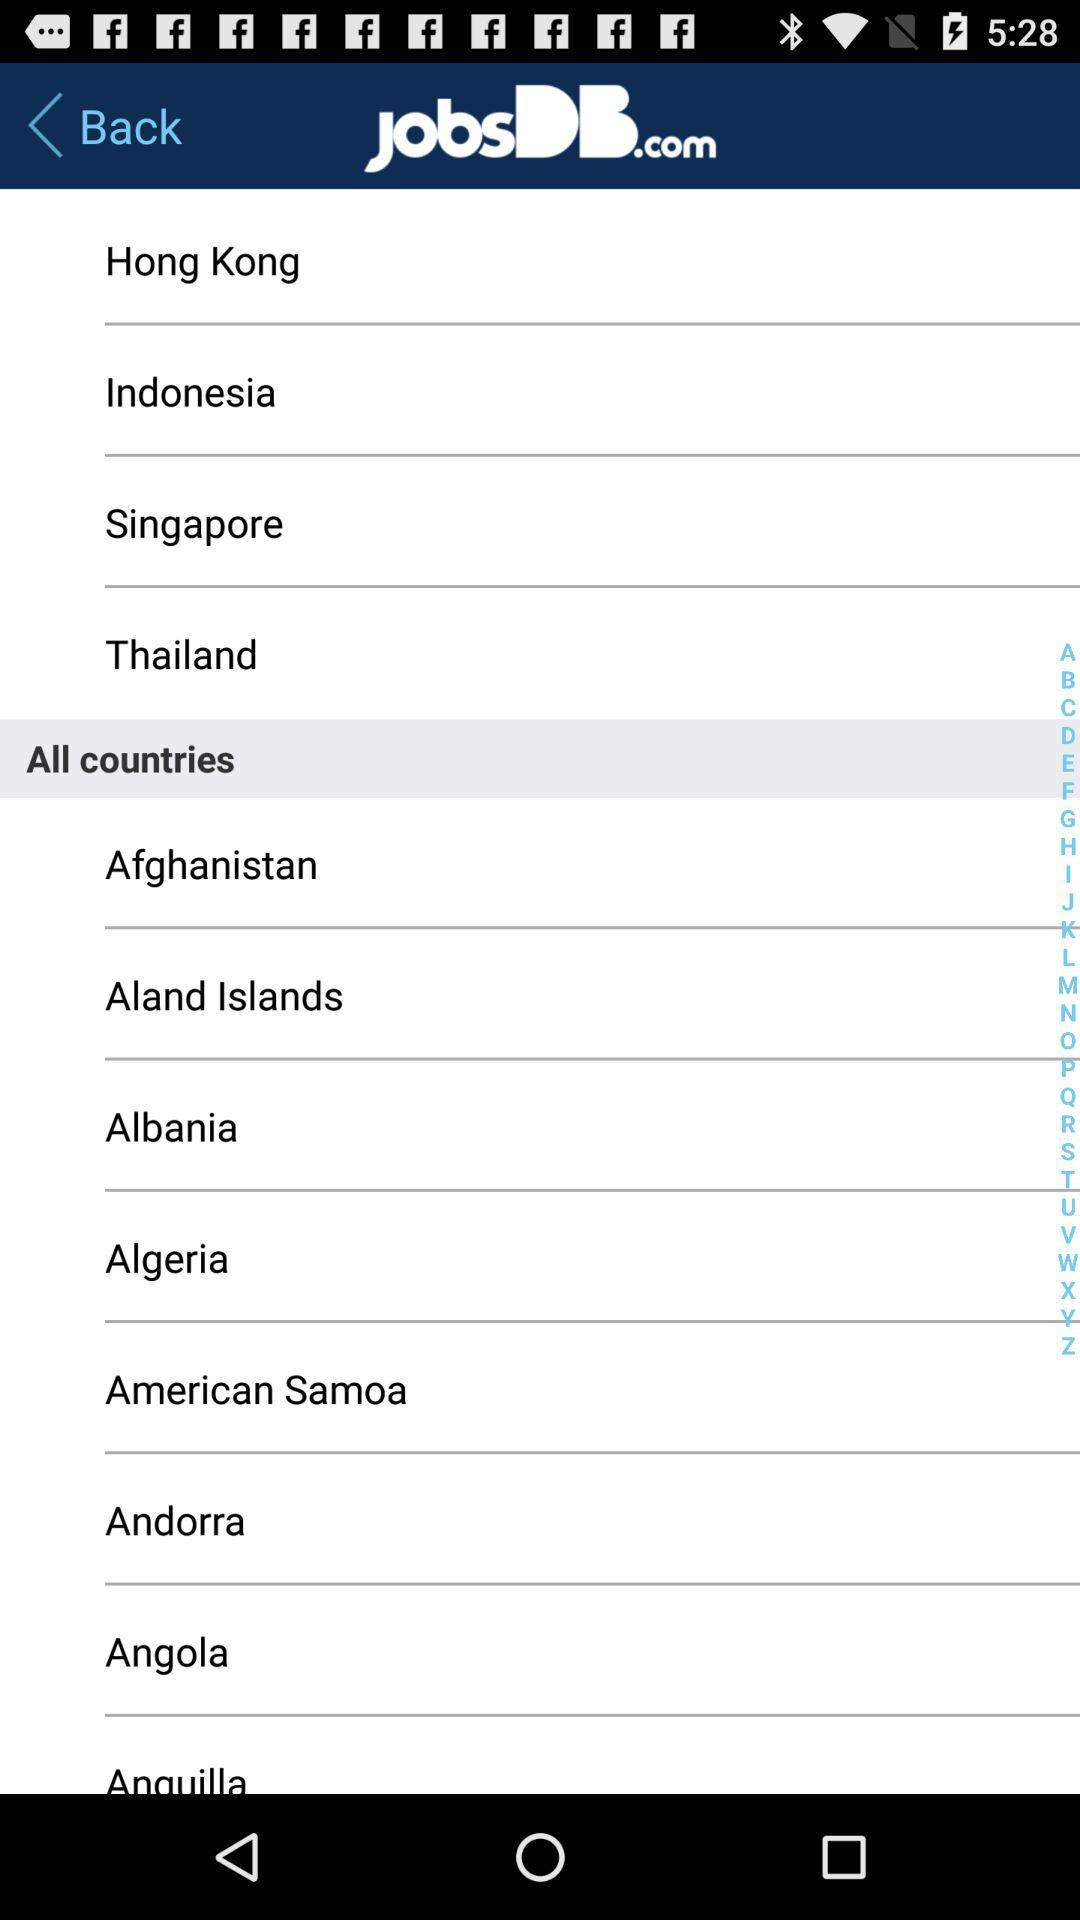What is the application name? The application name is "JobsDB.com". 